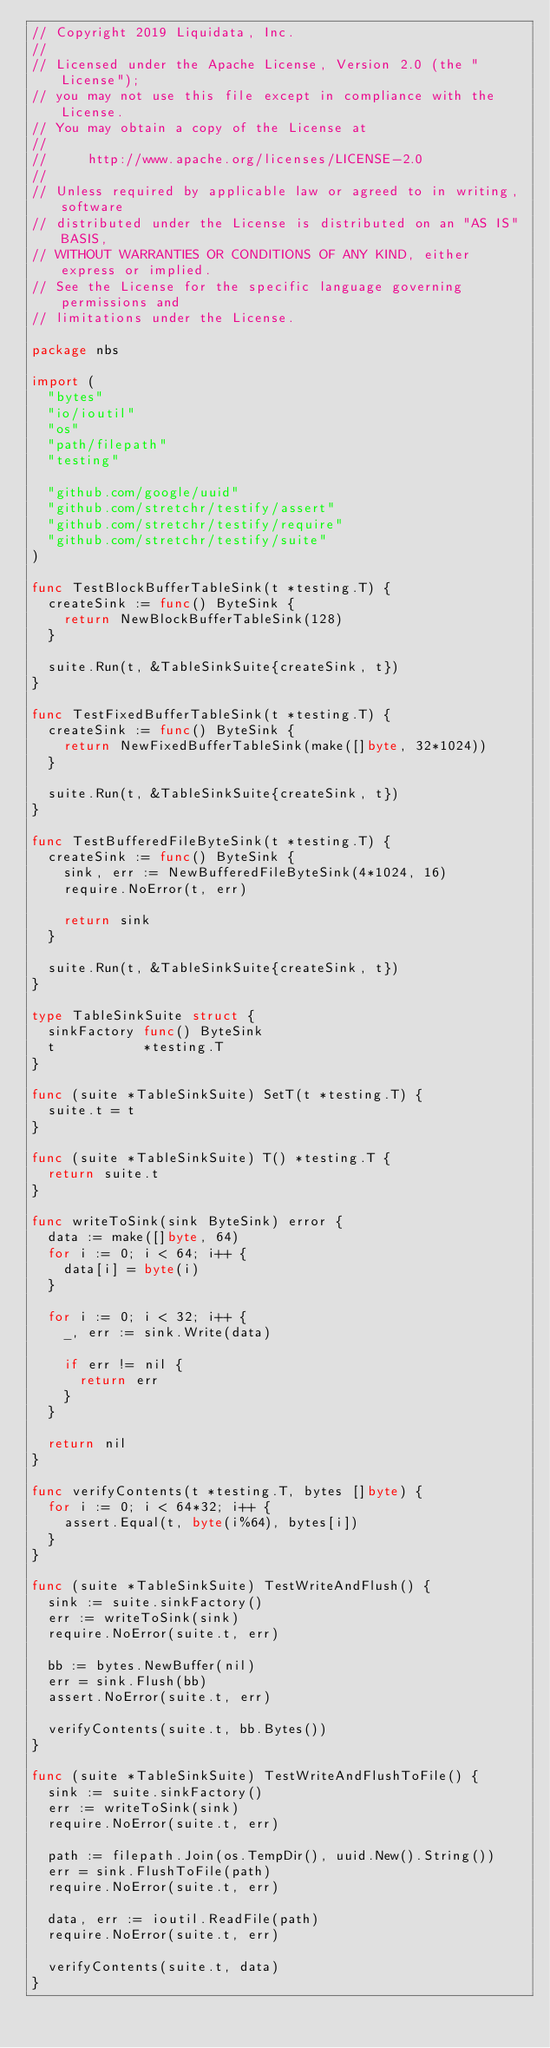<code> <loc_0><loc_0><loc_500><loc_500><_Go_>// Copyright 2019 Liquidata, Inc.
//
// Licensed under the Apache License, Version 2.0 (the "License");
// you may not use this file except in compliance with the License.
// You may obtain a copy of the License at
//
//     http://www.apache.org/licenses/LICENSE-2.0
//
// Unless required by applicable law or agreed to in writing, software
// distributed under the License is distributed on an "AS IS" BASIS,
// WITHOUT WARRANTIES OR CONDITIONS OF ANY KIND, either express or implied.
// See the License for the specific language governing permissions and
// limitations under the License.

package nbs

import (
	"bytes"
	"io/ioutil"
	"os"
	"path/filepath"
	"testing"

	"github.com/google/uuid"
	"github.com/stretchr/testify/assert"
	"github.com/stretchr/testify/require"
	"github.com/stretchr/testify/suite"
)

func TestBlockBufferTableSink(t *testing.T) {
	createSink := func() ByteSink {
		return NewBlockBufferTableSink(128)
	}

	suite.Run(t, &TableSinkSuite{createSink, t})
}

func TestFixedBufferTableSink(t *testing.T) {
	createSink := func() ByteSink {
		return NewFixedBufferTableSink(make([]byte, 32*1024))
	}

	suite.Run(t, &TableSinkSuite{createSink, t})
}

func TestBufferedFileByteSink(t *testing.T) {
	createSink := func() ByteSink {
		sink, err := NewBufferedFileByteSink(4*1024, 16)
		require.NoError(t, err)

		return sink
	}

	suite.Run(t, &TableSinkSuite{createSink, t})
}

type TableSinkSuite struct {
	sinkFactory func() ByteSink
	t           *testing.T
}

func (suite *TableSinkSuite) SetT(t *testing.T) {
	suite.t = t
}

func (suite *TableSinkSuite) T() *testing.T {
	return suite.t
}

func writeToSink(sink ByteSink) error {
	data := make([]byte, 64)
	for i := 0; i < 64; i++ {
		data[i] = byte(i)
	}

	for i := 0; i < 32; i++ {
		_, err := sink.Write(data)

		if err != nil {
			return err
		}
	}

	return nil
}

func verifyContents(t *testing.T, bytes []byte) {
	for i := 0; i < 64*32; i++ {
		assert.Equal(t, byte(i%64), bytes[i])
	}
}

func (suite *TableSinkSuite) TestWriteAndFlush() {
	sink := suite.sinkFactory()
	err := writeToSink(sink)
	require.NoError(suite.t, err)

	bb := bytes.NewBuffer(nil)
	err = sink.Flush(bb)
	assert.NoError(suite.t, err)

	verifyContents(suite.t, bb.Bytes())
}

func (suite *TableSinkSuite) TestWriteAndFlushToFile() {
	sink := suite.sinkFactory()
	err := writeToSink(sink)
	require.NoError(suite.t, err)

	path := filepath.Join(os.TempDir(), uuid.New().String())
	err = sink.FlushToFile(path)
	require.NoError(suite.t, err)

	data, err := ioutil.ReadFile(path)
	require.NoError(suite.t, err)

	verifyContents(suite.t, data)
}
</code> 